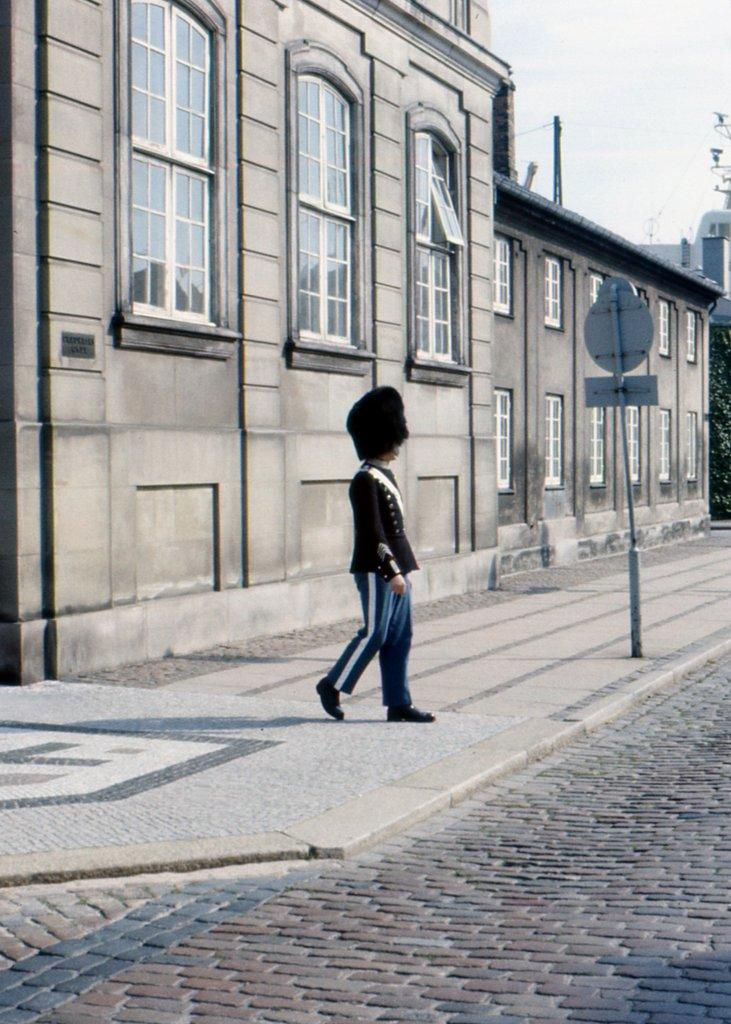What is the person in the image doing? There is a person walking in the image. What can be seen on the pole in the image? There are boards on a pole in the image. What type of structure is present in the image? There is a building in the image. What part of the building can be seen in the image? There are windows visible in the image. What is visible in the background of the image? The sky is visible in the image. What color is the coat in the person's pocket in the image? There is no coat or pocket mentioned in the image; the person is simply walking. 